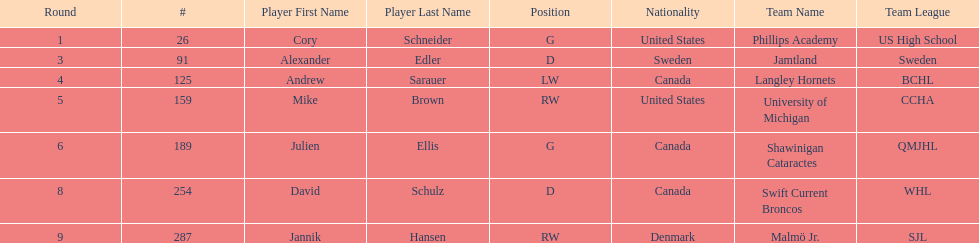How many canadian players are listed? 3. 